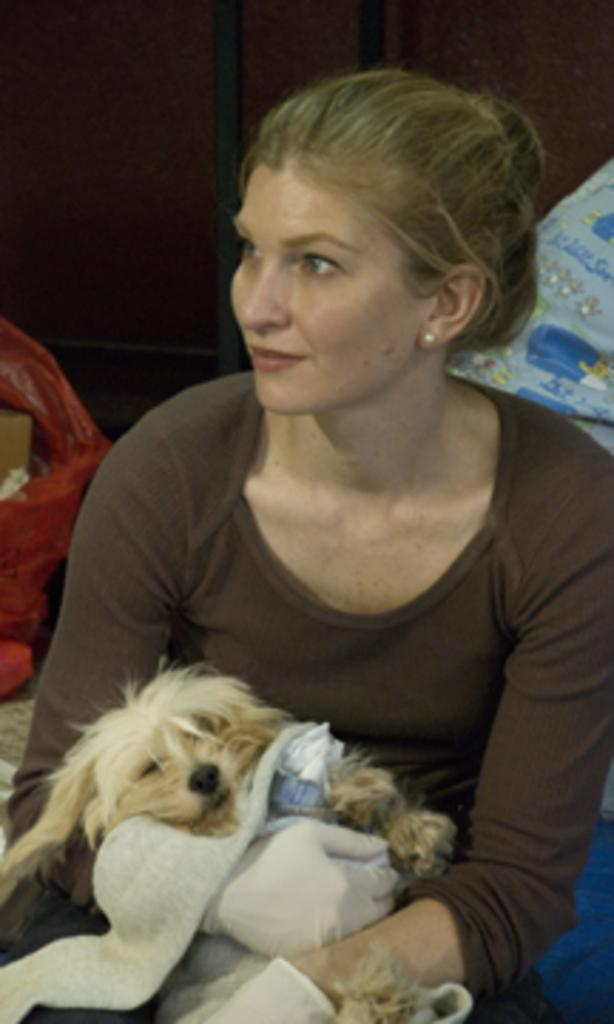Who is the main subject in the image? There is a woman in the image. What is the woman doing in the image? The woman is sitting. What is the woman wearing on her upper body? The woman is wearing a brown t-shirt. What is the woman wearing on her hands? The woman is wearing gloves. What is the woman holding in the image? The woman is holding a dog. What type of cream is the woman using to read the mind of her grandmother in the image? There is no mention of cream, reading minds, or grandmothers in the image. The image features a woman sitting, wearing a brown t-shirt and gloves, and holding a dog. 